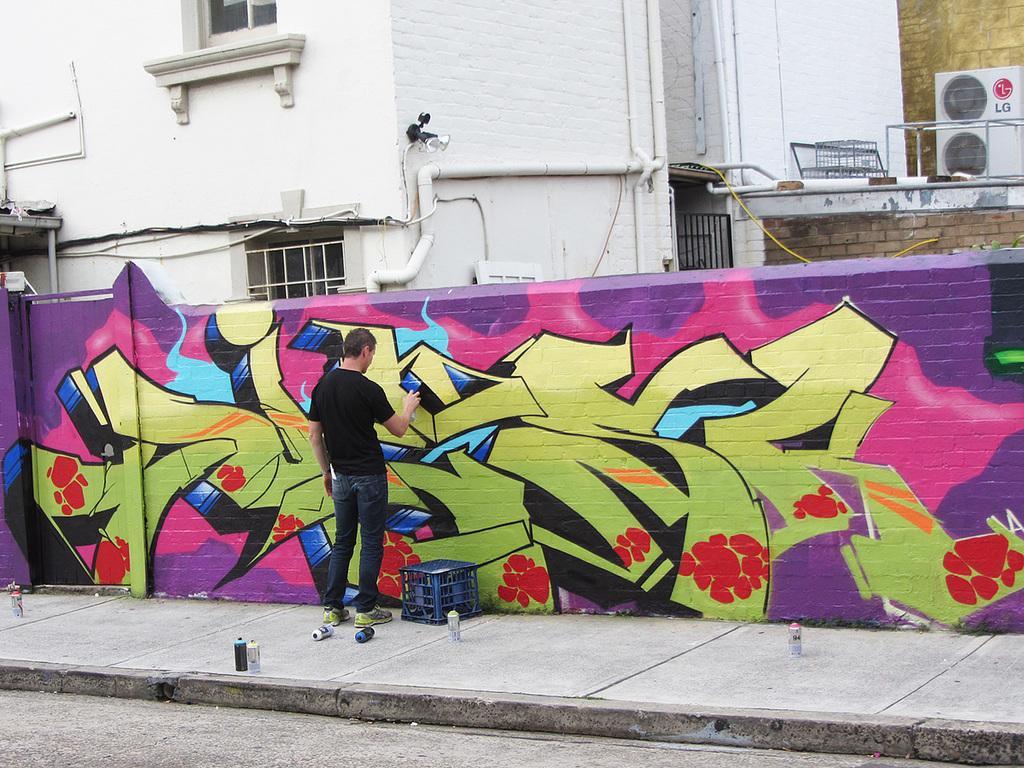In one or two sentences, can you explain what this image depicts? In this picture I can see a person painting on the wall, behind the wall we can see some buildings. 